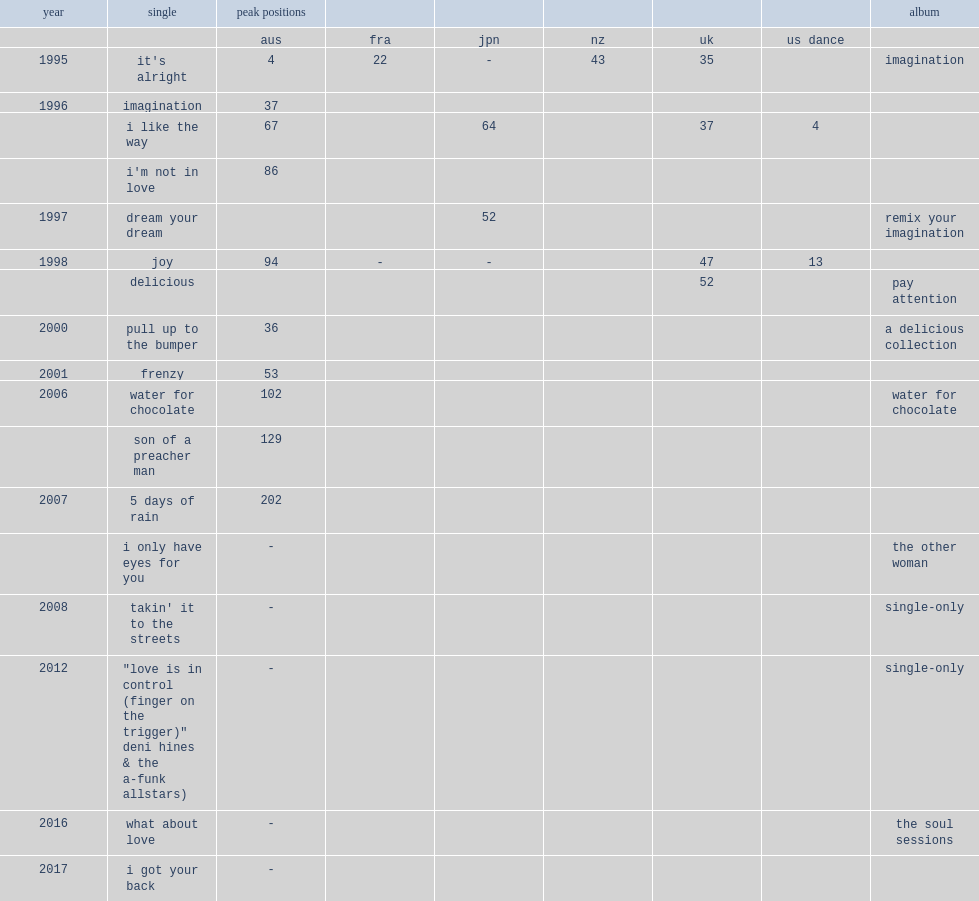Which deni hines's album was released in 2006 and features the singles "water for chocolate", "son of a preacher man" and "5 days of rain"? Water for chocolate. 